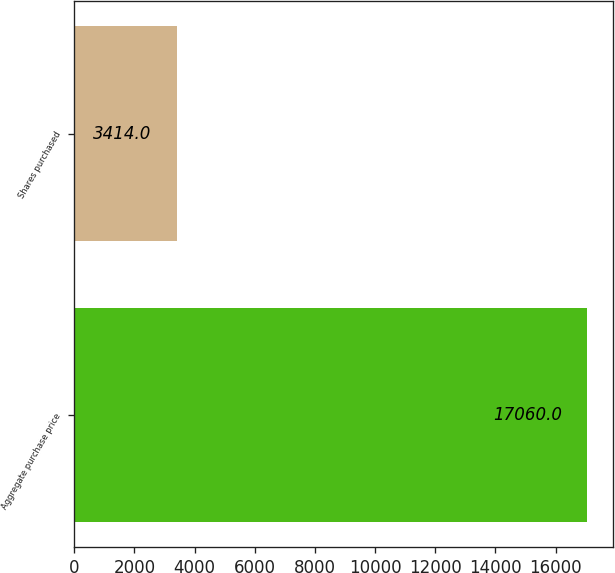Convert chart. <chart><loc_0><loc_0><loc_500><loc_500><bar_chart><fcel>Aggregate purchase price<fcel>Shares purchased<nl><fcel>17060<fcel>3414<nl></chart> 